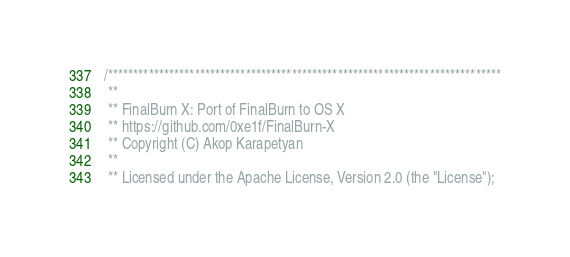Convert code to text. <code><loc_0><loc_0><loc_500><loc_500><_ObjectiveC_>/*****************************************************************************
 **
 ** FinalBurn X: Port of FinalBurn to OS X
 ** https://github.com/0xe1f/FinalBurn-X
 ** Copyright (C) Akop Karapetyan
 **
 ** Licensed under the Apache License, Version 2.0 (the "License");</code> 